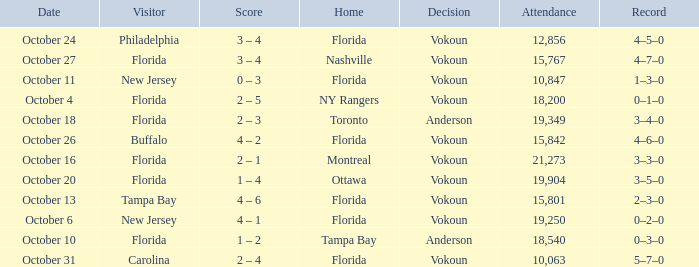What was the score on October 13? 4 – 6. 